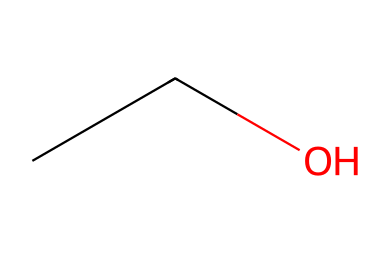What is the name of the chemical represented by this SMILES? The SMILES "CCO" corresponds to the molecular structure of ethanol, which is a simple alcohol. The "C" symbols represent carbon atoms, and "O" represents an oxygen atom. The structure can be visualized as two carbon atoms connected to each other and one carbon connected to a hydroxyl group (—OH). This combination is characteristic of ethanol, which is a common component in alcoholic beverages, including Cava.
Answer: ethanol How many carbon atoms are present in this chemical? The SMILES "CCO" indicates that there are two "C" symbols, meaning two carbon atoms are present in the structure. Each "C" stands for a single carbon atom, so counting them gives a total of two.
Answer: 2 What type of alcohol is indicated by this molecule? The presence of the —OH group attached to the carbon chain in the structure of "CCO" classifies it as an alcohol. Given that it has a simple two-carbon structure, it identifies as a primary alcohol, specifically ethanol.
Answer: primary alcohol How many hydrogen atoms are associated with this chemical? The structure "CCO" corresponds to ethanol, which follows the general formula for alkanes (CnH2n+2) being modified slightly due to the —OH group. Therefore, for 2 carbons (n=2), the formula gives 2(2) + 1 = 5 hydrogen atoms in total, accounting for the loss of one hydrogen when the —OH is included.
Answer: 6 Which part of the chemical structure highlights its solubility in water? The presence of the hydroxyl group (—OH) in "CCO" is responsible for the molecule's hydrophilic nature. The oxygen atom of the hydroxyl group can form hydrogen bonds with water molecules, which significantly increases the solubility of the molecule in water.
Answer: hydroxyl group What is the functional group present in this chemical? In the structure "CCO," the hydroxyl group (—OH) is the functional group present. Functional groups characterize the behavior of organic molecules, and in this case, it defines it as an alcohol. The presence of this group is what differentiates ethanol from other types of organic compounds.
Answer: hydroxyl group 